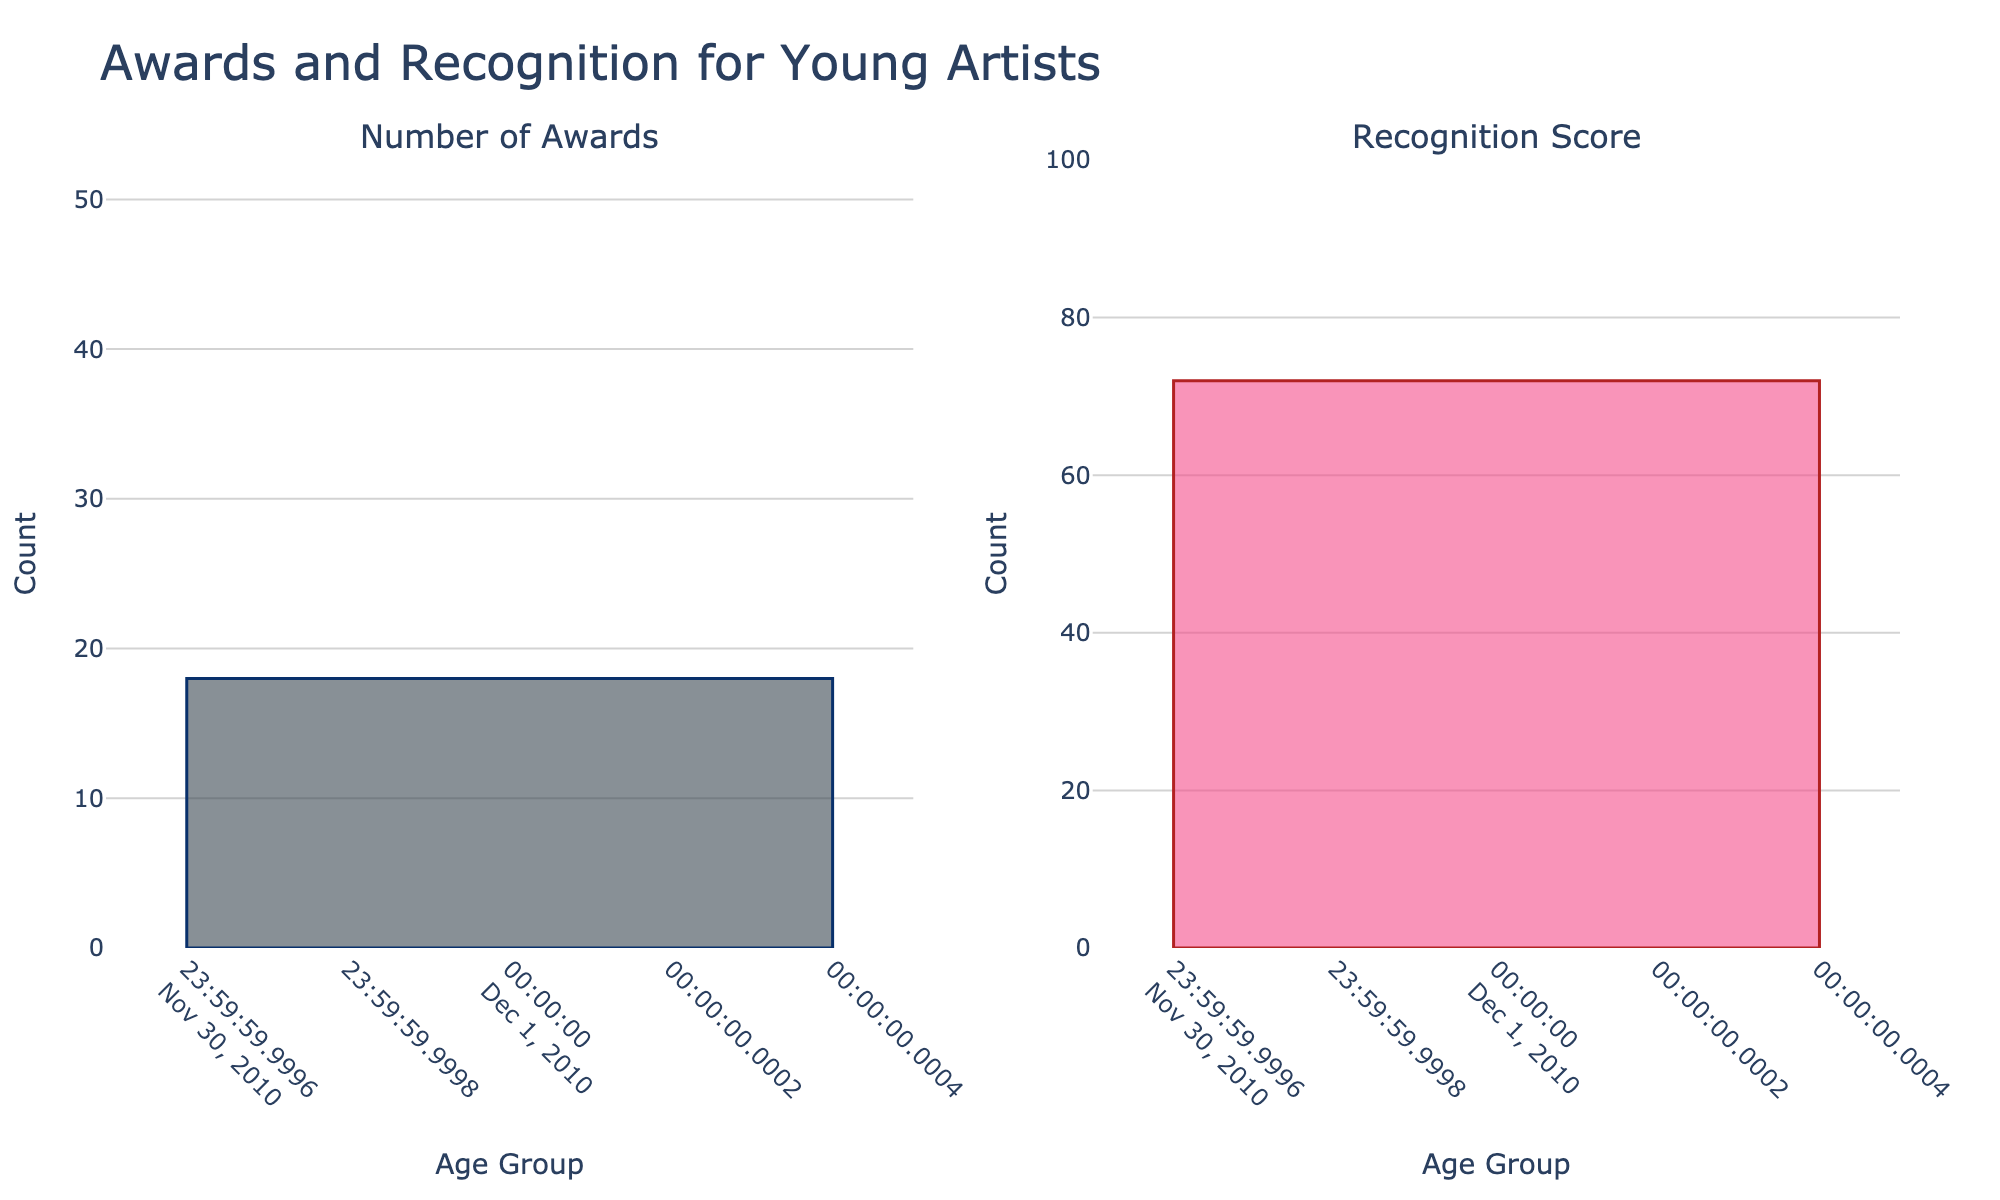What is the age group with the highest number of awards? The bar representing the "22-25" age group is the tallest in the "Number of Awards" subplot, indicating they received the most awards.
Answer: 22-25 What is the age group with the lowest recognition score? The bar representing the "Under 10" age group is the shortest in the "Recognition Score" subplot, indicating they have the lowest recognition score.
Answer: Under 10 By how much does the number of awards for the 16-18 age group surpass that of the 13-15 age group? The number of awards for the 16-18 age group is 35, and for the 13-15 age group, it is 25. The difference is 35 - 25 = 10.
Answer: 10 What is the average recognition score across all age groups? The recognition scores are 65, 72, 80, 88, 92, and 95. Summing these gives 492. Dividing by the 6 age groups, the average score is 492 / 6 = 82.
Answer: 82 Which has a greater difference between the highest and lowest values: the number of awards or the recognition score? The range for the number of awards is 50 - 12 = 38 and for the recognition score, it is 95 - 65 = 30. The number of awards has the greater difference.
Answer: Number of Awards What is the total number of awards received by artists under 12 years old? The number of awards for the "Under 10" group is 12 and for the "10-12" group is 18. Summing these gives 12 + 18 = 30.
Answer: 30 Which age group sees the most significant improvement in recognition score compared to the previous age group? The recognition scores are: Under 10 - 65, 10-12 - 72, 13-15 - 80, 16-18 - 88, 19-21 - 92, 22-25 - 95. Comparing differences: 
72 - 65 = 7, 80 - 72 = 8, 88 - 80 = 8, 92 - 88 = 4, 95 - 92 = 3. The 13-15 and 16-18 groups both see the biggest increase by 8 points.
Answer: 13-15 and 16-18 What is the combined recognition score for artists aged 16-21? The recognition scores for the "16-18" group and the "19-21" group are 88 and 92 respectively, summing gives 88 + 92 = 180.
Answer: 180 What is the percent increase in the number of awards from the 10-12 age group to the 13-15 age group? The number of awards for the 10-12 group is 18 and for the 13-15 group it is 25. The percent increase is ((25-18)/18) * 100 ≈ 38.89%.
Answer: 38.89% Which age group has a recognition score closest to the average recognition score of 82? The recognition scores are: 65, 72, 80, 88, 92, and 95. The closest to 82 is 80 from the "13-15" age group.
Answer: 13-15 